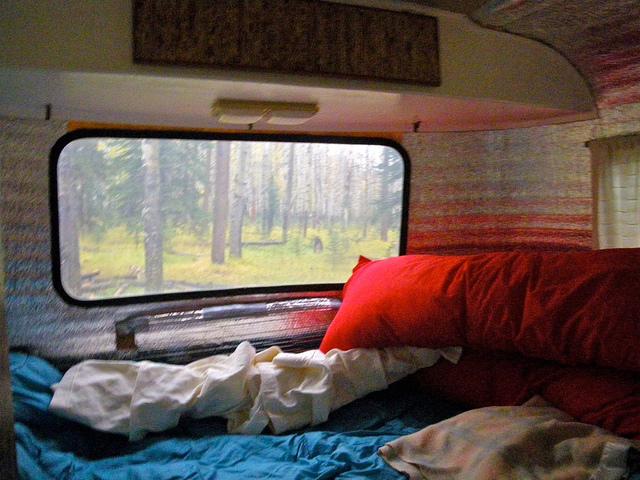Is there someone on the bed?
Be succinct. No. What color is the pillow?
Concise answer only. Red. Is this inside a trailer?
Short answer required. Yes. 